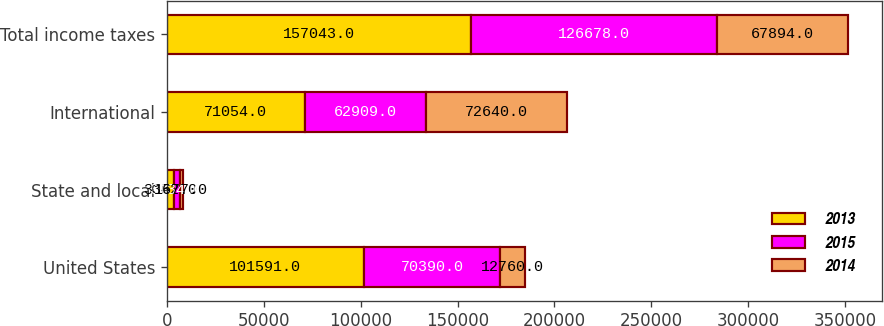Convert chart. <chart><loc_0><loc_0><loc_500><loc_500><stacked_bar_chart><ecel><fcel>United States<fcel>State and local<fcel>International<fcel>Total income taxes<nl><fcel>2013<fcel>101591<fcel>3352<fcel>71054<fcel>157043<nl><fcel>2015<fcel>70390<fcel>3134<fcel>62909<fcel>126678<nl><fcel>2014<fcel>12760<fcel>1677<fcel>72640<fcel>67894<nl></chart> 